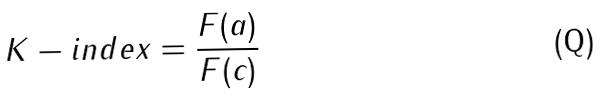Convert formula to latex. <formula><loc_0><loc_0><loc_500><loc_500>K - i n d e x = \frac { F ( a ) } { F ( c ) }</formula> 